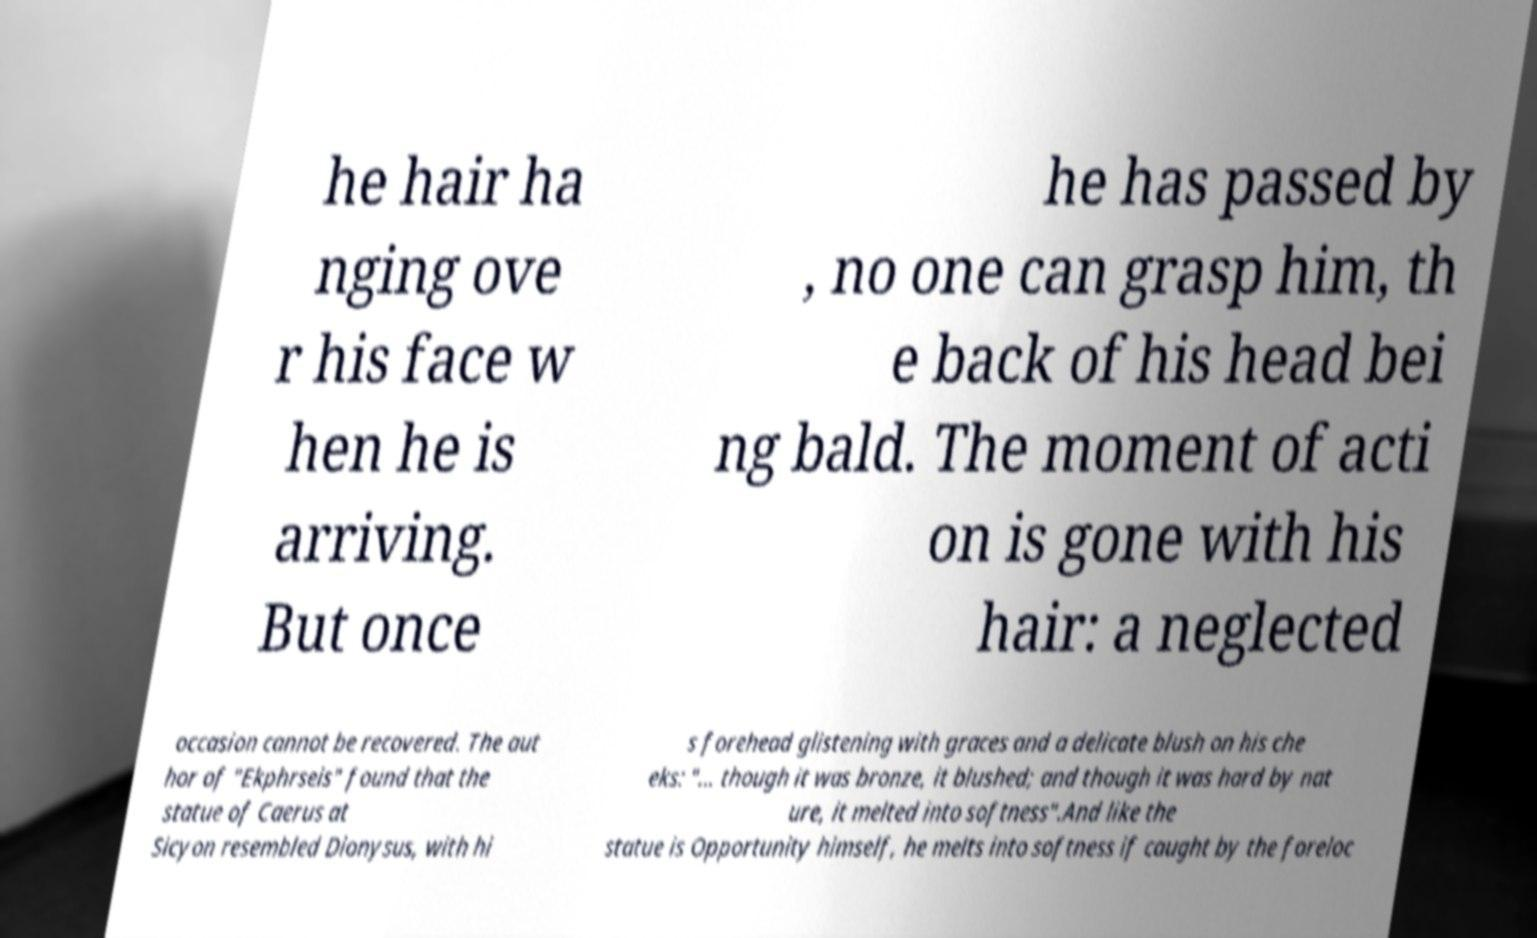Could you assist in decoding the text presented in this image and type it out clearly? he hair ha nging ove r his face w hen he is arriving. But once he has passed by , no one can grasp him, th e back of his head bei ng bald. The moment of acti on is gone with his hair: a neglected occasion cannot be recovered. The aut hor of "Ekphrseis" found that the statue of Caerus at Sicyon resembled Dionysus, with hi s forehead glistening with graces and a delicate blush on his che eks: "... though it was bronze, it blushed; and though it was hard by nat ure, it melted into softness".And like the statue is Opportunity himself, he melts into softness if caught by the foreloc 